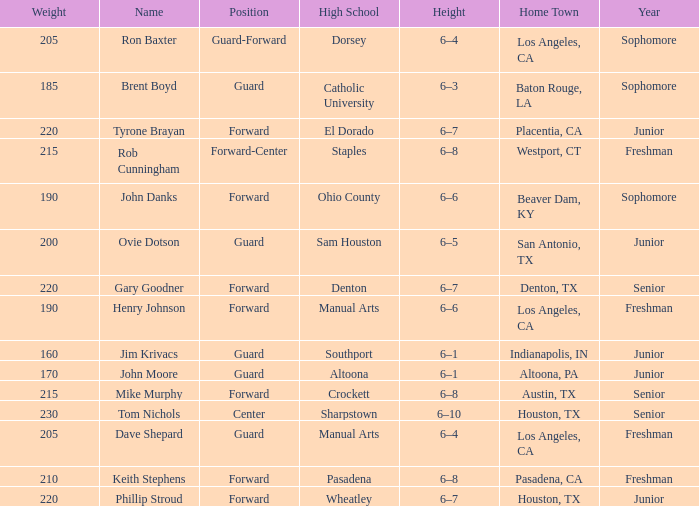What is the home town called with rob cunningham? Westport, CT. 